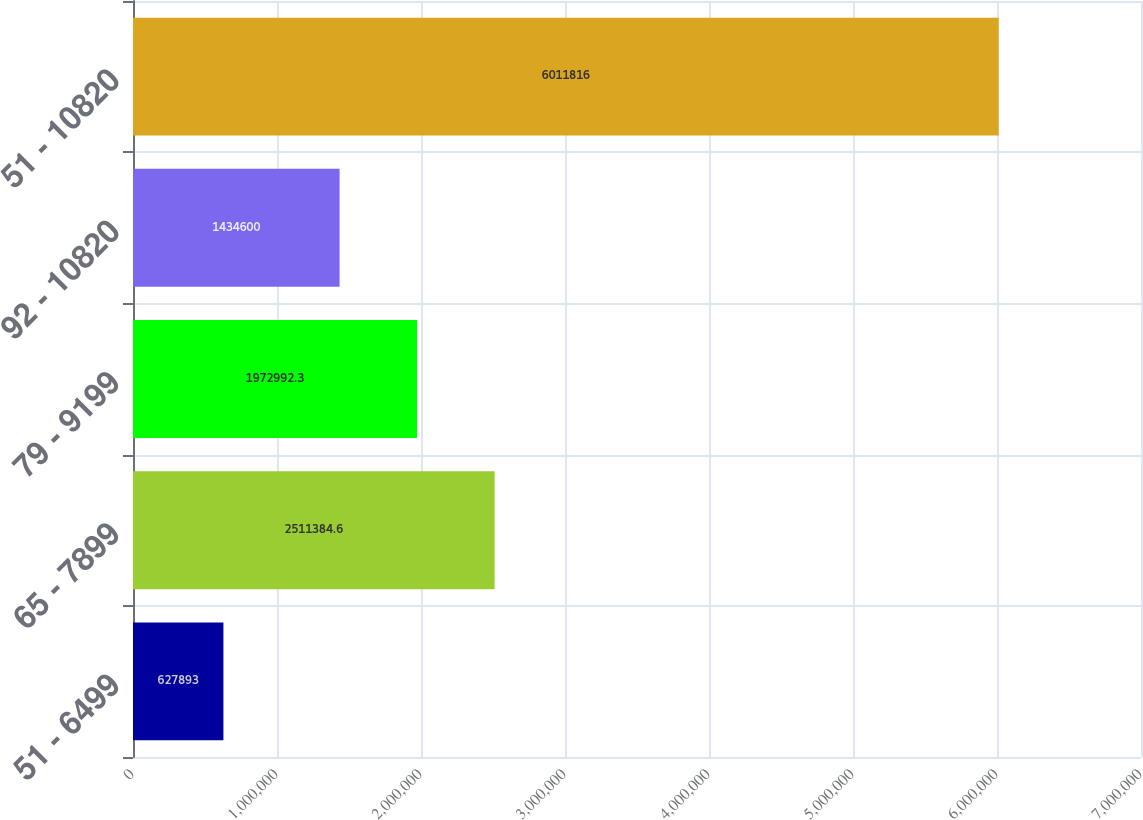<chart> <loc_0><loc_0><loc_500><loc_500><bar_chart><fcel>51 - 6499<fcel>65 - 7899<fcel>79 - 9199<fcel>92 - 10820<fcel>51 - 10820<nl><fcel>627893<fcel>2.51138e+06<fcel>1.97299e+06<fcel>1.4346e+06<fcel>6.01182e+06<nl></chart> 